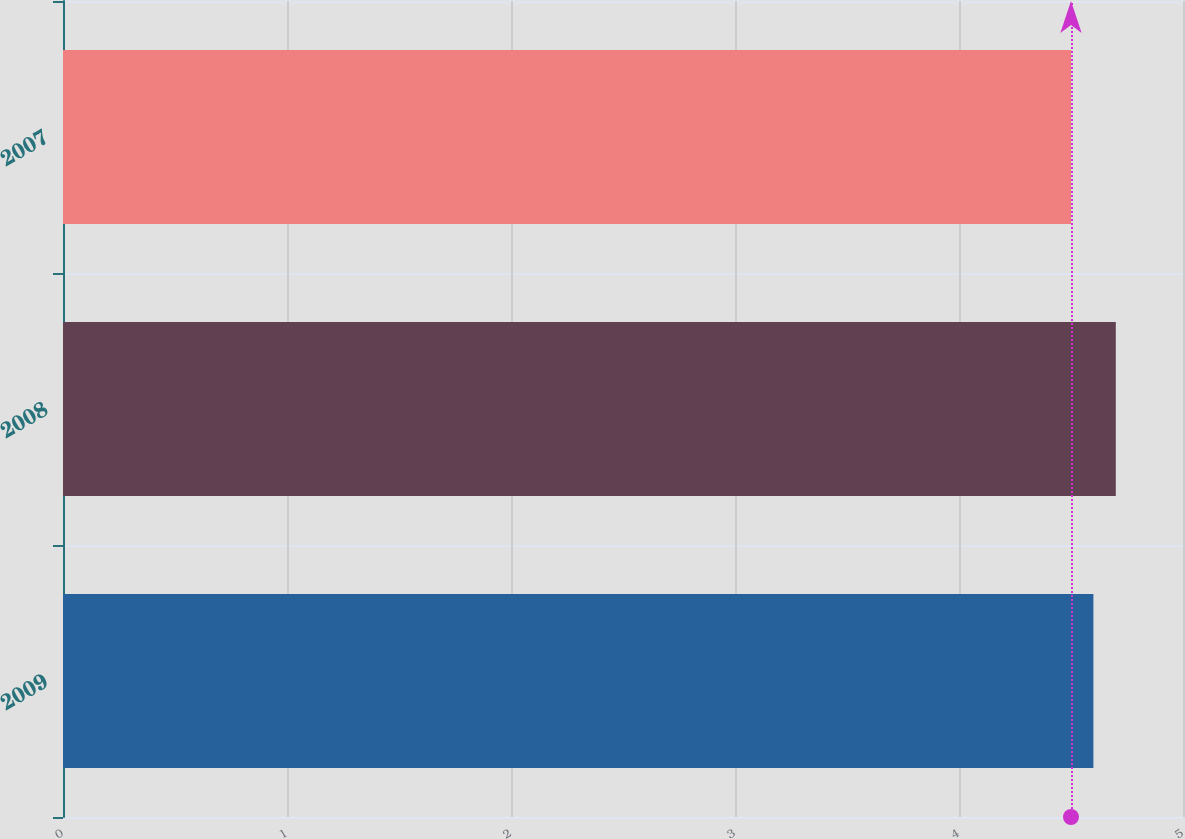<chart> <loc_0><loc_0><loc_500><loc_500><bar_chart><fcel>2009<fcel>2008<fcel>2007<nl><fcel>4.6<fcel>4.7<fcel>4.5<nl></chart> 